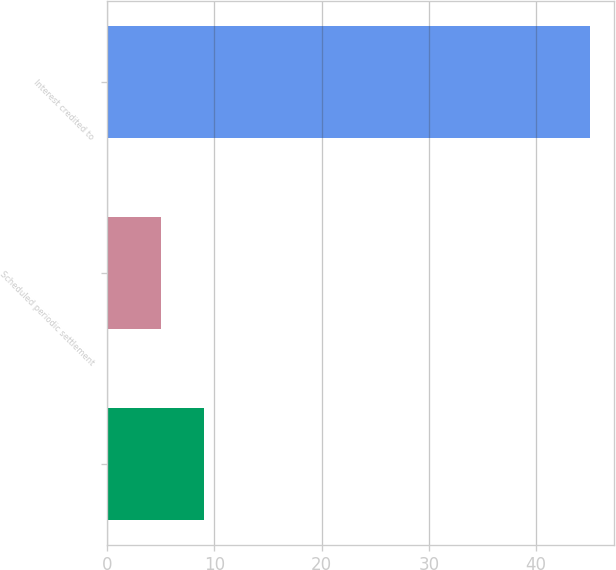Convert chart to OTSL. <chart><loc_0><loc_0><loc_500><loc_500><bar_chart><ecel><fcel>Scheduled periodic settlement<fcel>Interest credited to<nl><fcel>9<fcel>5<fcel>45<nl></chart> 